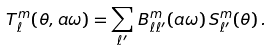<formula> <loc_0><loc_0><loc_500><loc_500>T ^ { m } _ { \ell } ( \theta , a \omega ) = \sum _ { \ell ^ { \prime } } \, B _ { \ell \ell ^ { \prime } } ^ { m } ( a \omega ) \, S _ { \ell ^ { \prime } } ^ { m } ( \theta ) \, .</formula> 